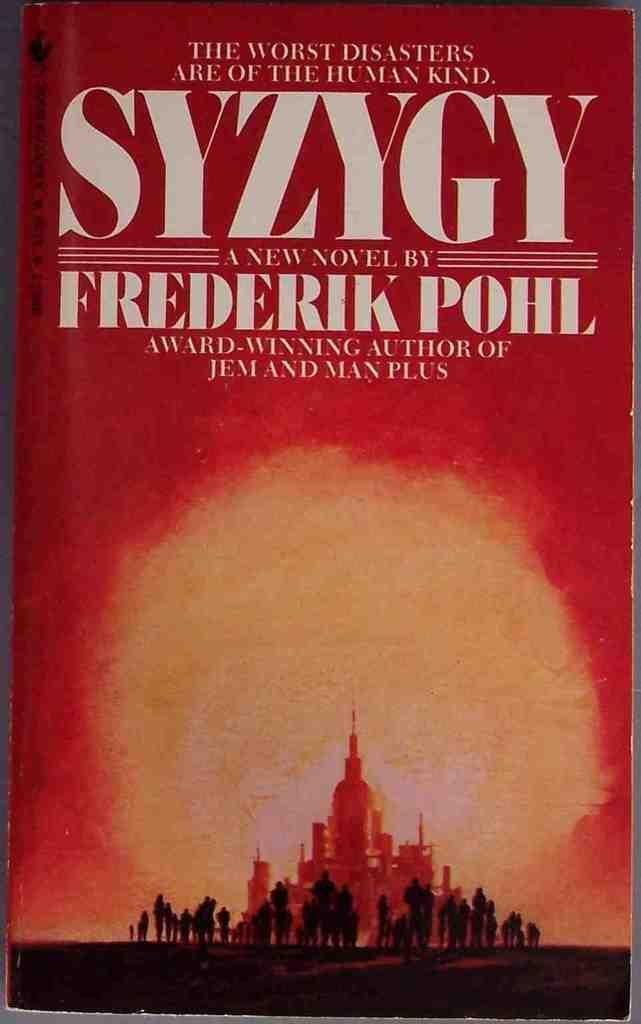<image>
Relay a brief, clear account of the picture shown. A book by Frederik Pohl has a red cover and is titled Syzygy. 